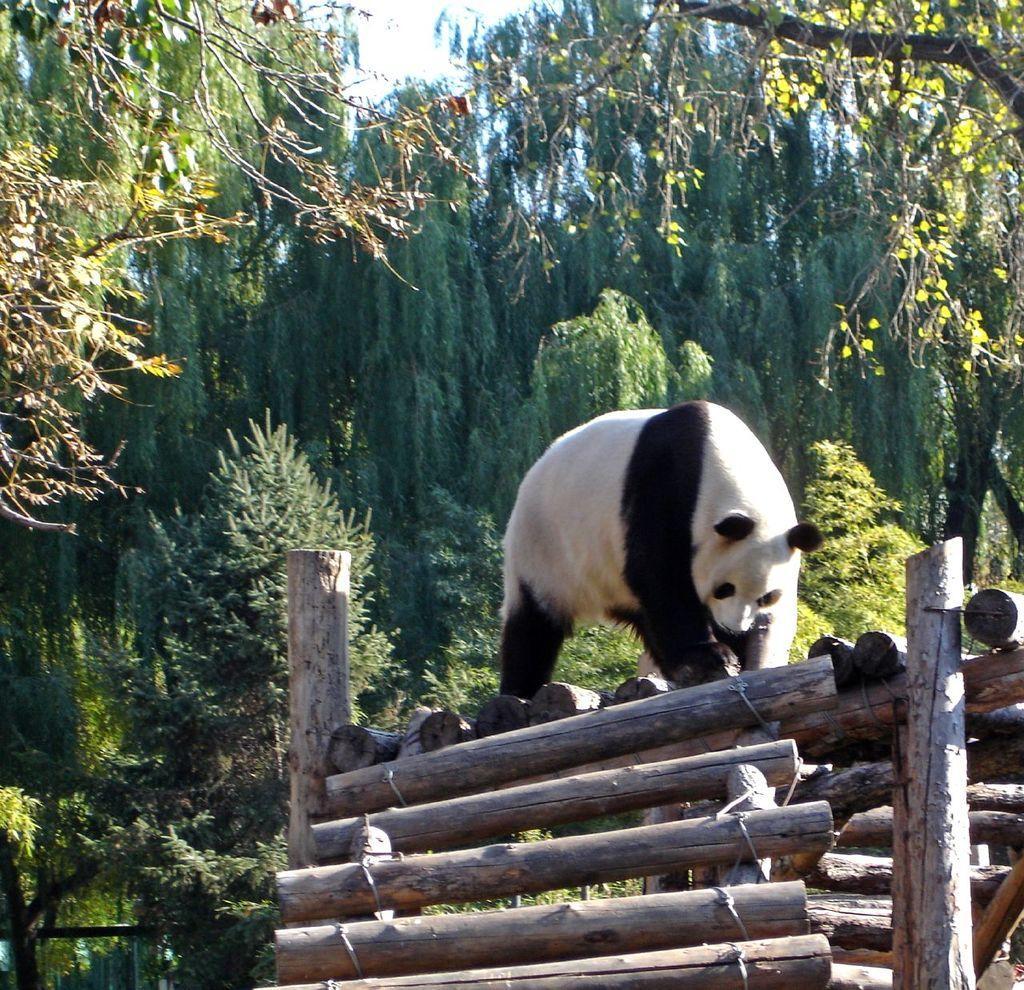How would you summarize this image in a sentence or two? This picture is clicked outside the city. In the foreground we can see the wooden bamboos. In the center there is a panda. In the background we can see sky, trees and plants. 